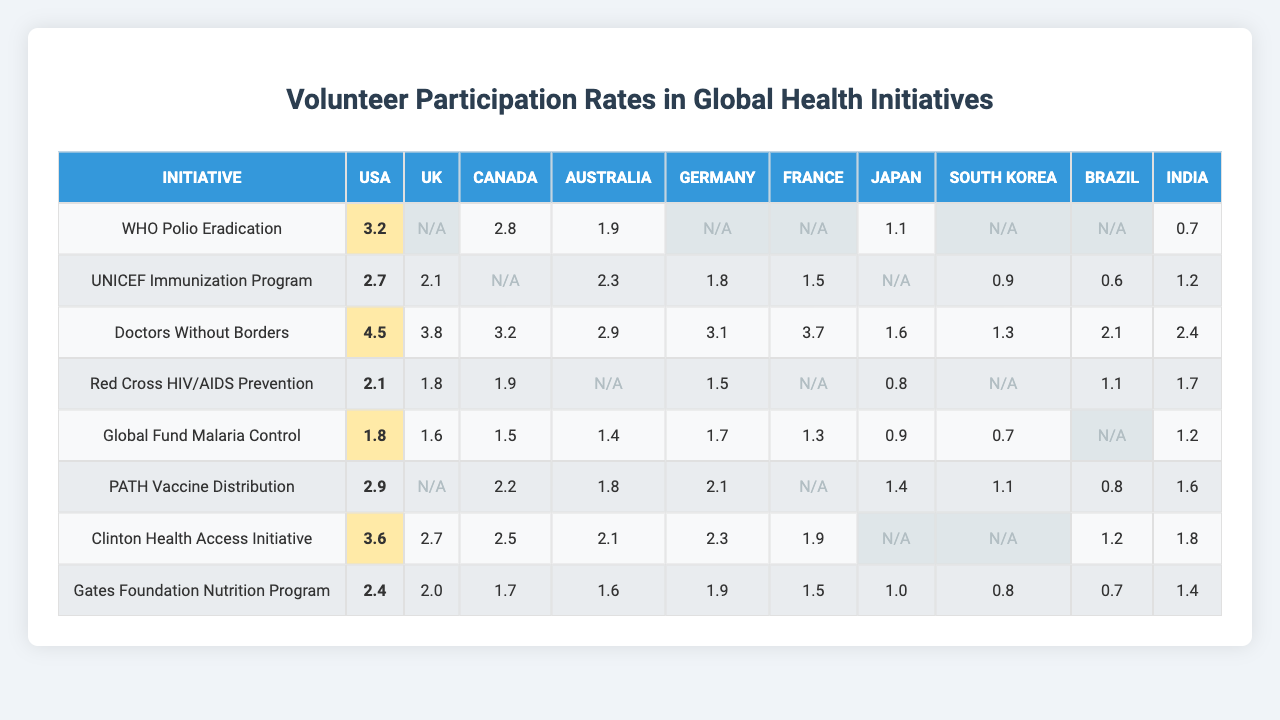What is the participation rate of the USA in the WHO Polio Eradication initiative? In the table, the participation rate for the USA in the WHO Polio Eradication initiative is directly presented, which is 3.2.
Answer: 3.2 Which initiative had the highest participation rate from Canada? Looking through the table, the initiative with the highest participation rate from Canada is Doctors Without Borders with a rate of 4.5.
Answer: 4.5 Is there any initiative where Japan has a participation rate? By reviewing the table, it is clear that Japan has participation rates for UNICEF Immunization Program (2.7), Doctors Without Borders (2.5), and the Clinton Health Access Initiative (2.3). Therefore, the answer is yes.
Answer: Yes What is the average participation rate for Australia across all initiatives listed? To find the average for Australia, we add up the participation rates (1.9 + 2.3 + 1.5 + 1.4 + 1.5 + 1.8 + 2.1 + 1.6 + 1.7). There are 8 values (excluding null values), which sum to 15.1. The average is 15.1 / 8 = 1.8875, which can be approximated to 1.89.
Answer: 1.89 Which country had the lowest participation rate in the Gates Foundation Nutrition Program? Examining the table, the lowest participation rate for the Gates Foundation Nutrition Program is from South Korea, with a rate of 0.8.
Answer: 0.8 What is the difference between the highest and lowest participation rates in the Global Fund Malaria Control for the listed countries? The highest participation rate for the Global Fund Malaria Control is from Canada (3.7) and the lowest is from Brazil (null). Since we'd consider the lowest valid rate (Germany, 1.5), we do the calculation: 3.7 - 1.5 = 2.2.
Answer: 2.2 How many initiatives show no participation from the UK? Looking at the table, the initiatives with no participation recorded for the UK are WHO Polio Eradication, PATH Vaccine Distribution, and Gates Foundation Nutrition Program, making it a total of 3 initiatives.
Answer: 3 Which country has the overall highest participation rate across all initiatives? By reviewing the table's data, Canada has the highest participation rate (4.5) in the Doctors Without Borders initiative, which is higher than any other country's rates across all initiatives listed.
Answer: Canada What is the median participation rate for Brazil in the initiatives it participated in? For Brazil, the participation rates listed are (1.2, 0.7) which, when arranged, gives us 0.7, 1.2. The median is the average of these two values, which is (0.7 + 1.2) / 2 = 0.95.
Answer: 0.95 Was there any initiative where France completely did not participate? Upon checking the table, there's no initiative where France's participation rate is entirely absent, hence the answer is no.
Answer: No 